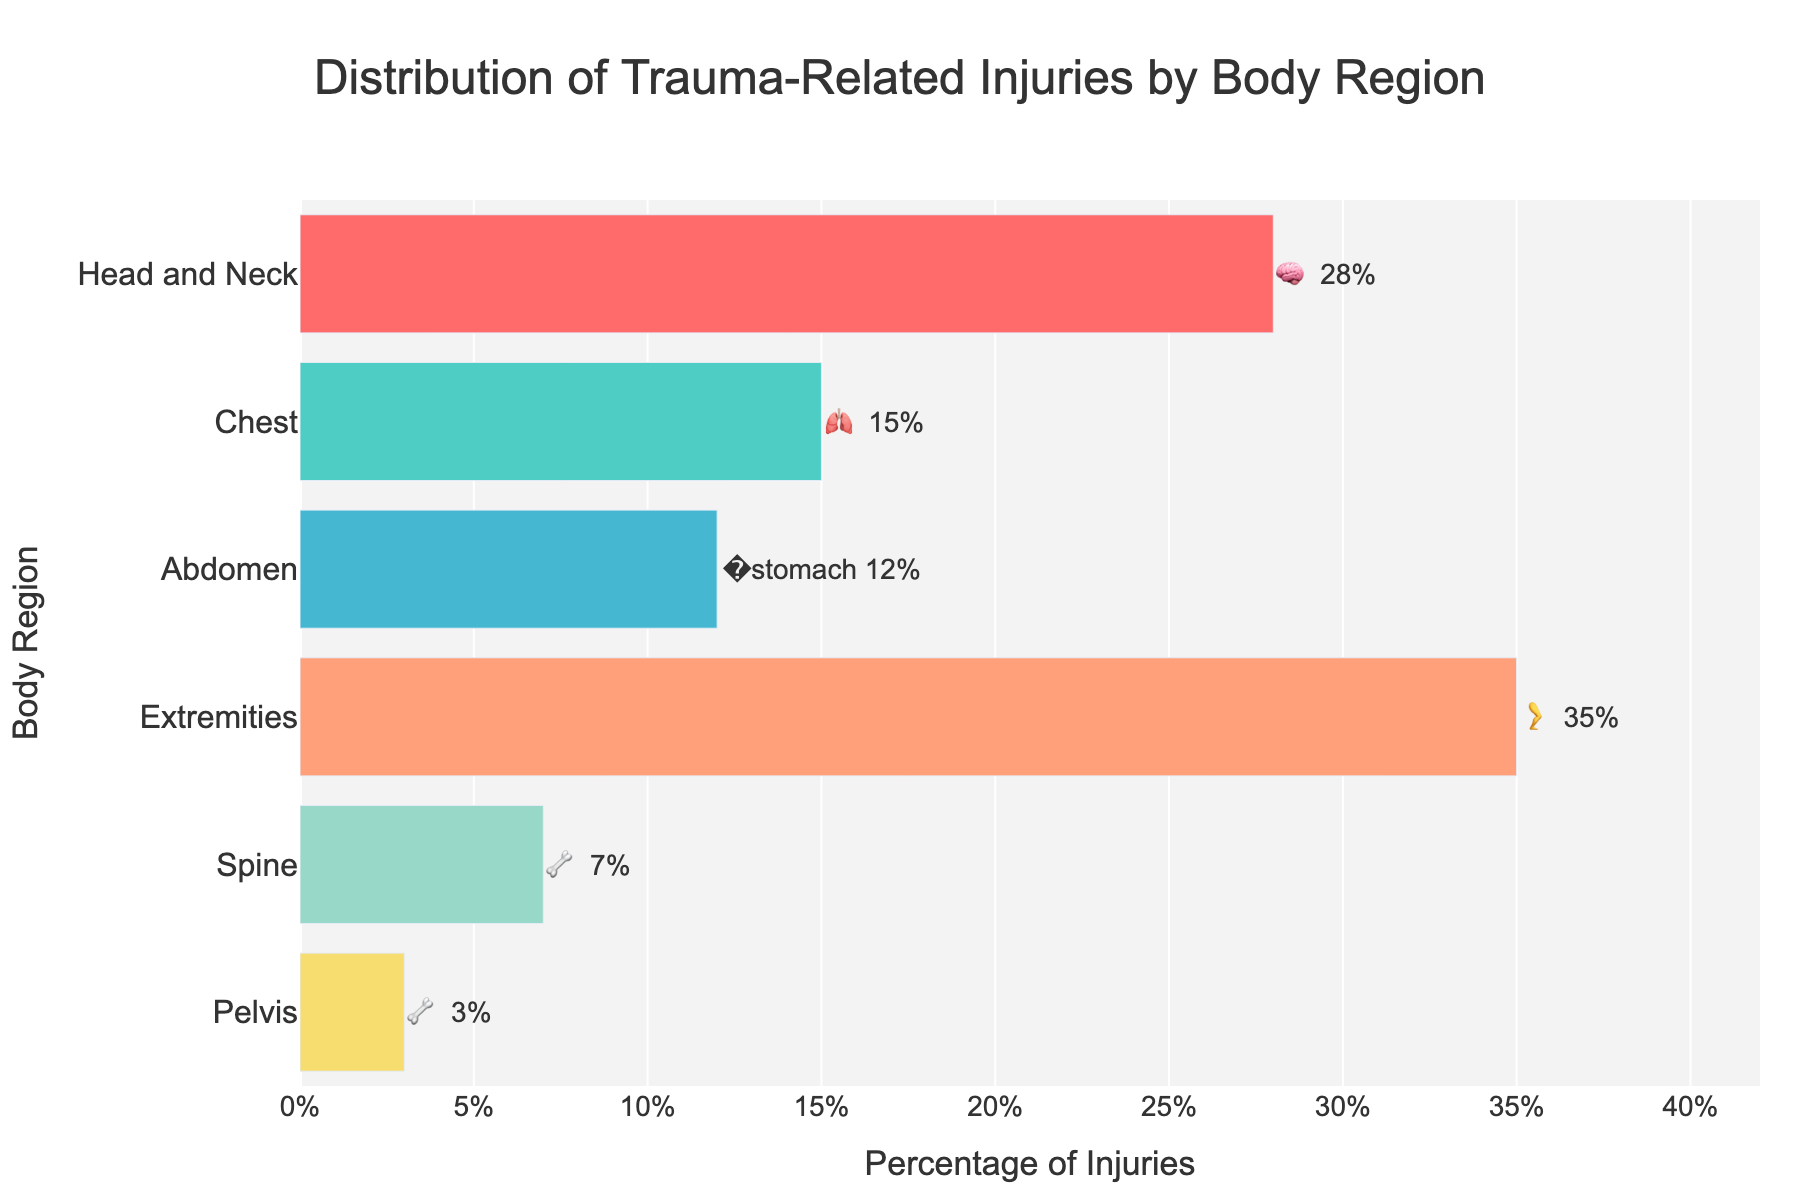What's the title of the figure? The title is displayed at the top of the figure.
Answer: Distribution of Trauma-Related Injuries by Body Region Which body region has the highest percentage of trauma-related injuries? The highest bar on the chart represents the body region with the highest percentage.
Answer: Extremities What is the percentage of trauma-related injuries in the chest region? Look for the bar labeled 'Chest' and read the percentage value.
Answer: 15% How much more common are trauma-related injuries to the head and neck than to the spine? Find the percentages for both head and neck (28%) and spine (7%) and subtract the latter from the former: 28% - 7%.
Answer: 21% Which body region has the lowest percentage of trauma-related injuries? The shortest bar on the chart represents the body region with the lowest percentage.
Answer: Pelvis What is the sum of the percentages of trauma-related injuries to the chest and abdomen? Add the percentages for chest (15%) and abdomen (12%): 15% + 12%.
Answer: 27% Are injuries to the abdomen more common than injuries to the spine? Compare the percentages: abdomen (12%) and spine (7%).
Answer: Yes What is the combined percentage of injuries to the head and neck and extremities? Add the percentages for head and neck (28%) and extremities (35%): 28% + 35%.
Answer: 63% Which body regions have the same emoji representing them in the figure? Look for regions that share the same emoji symbol in the text labels.
Answer: Spine and Pelvis What is the percentage difference between trauma-related injuries to the chest and pelvis? Subtract the percentage for pelvis (3%) from the percentage for chest (15%): 15% - 3%.
Answer: 12% 